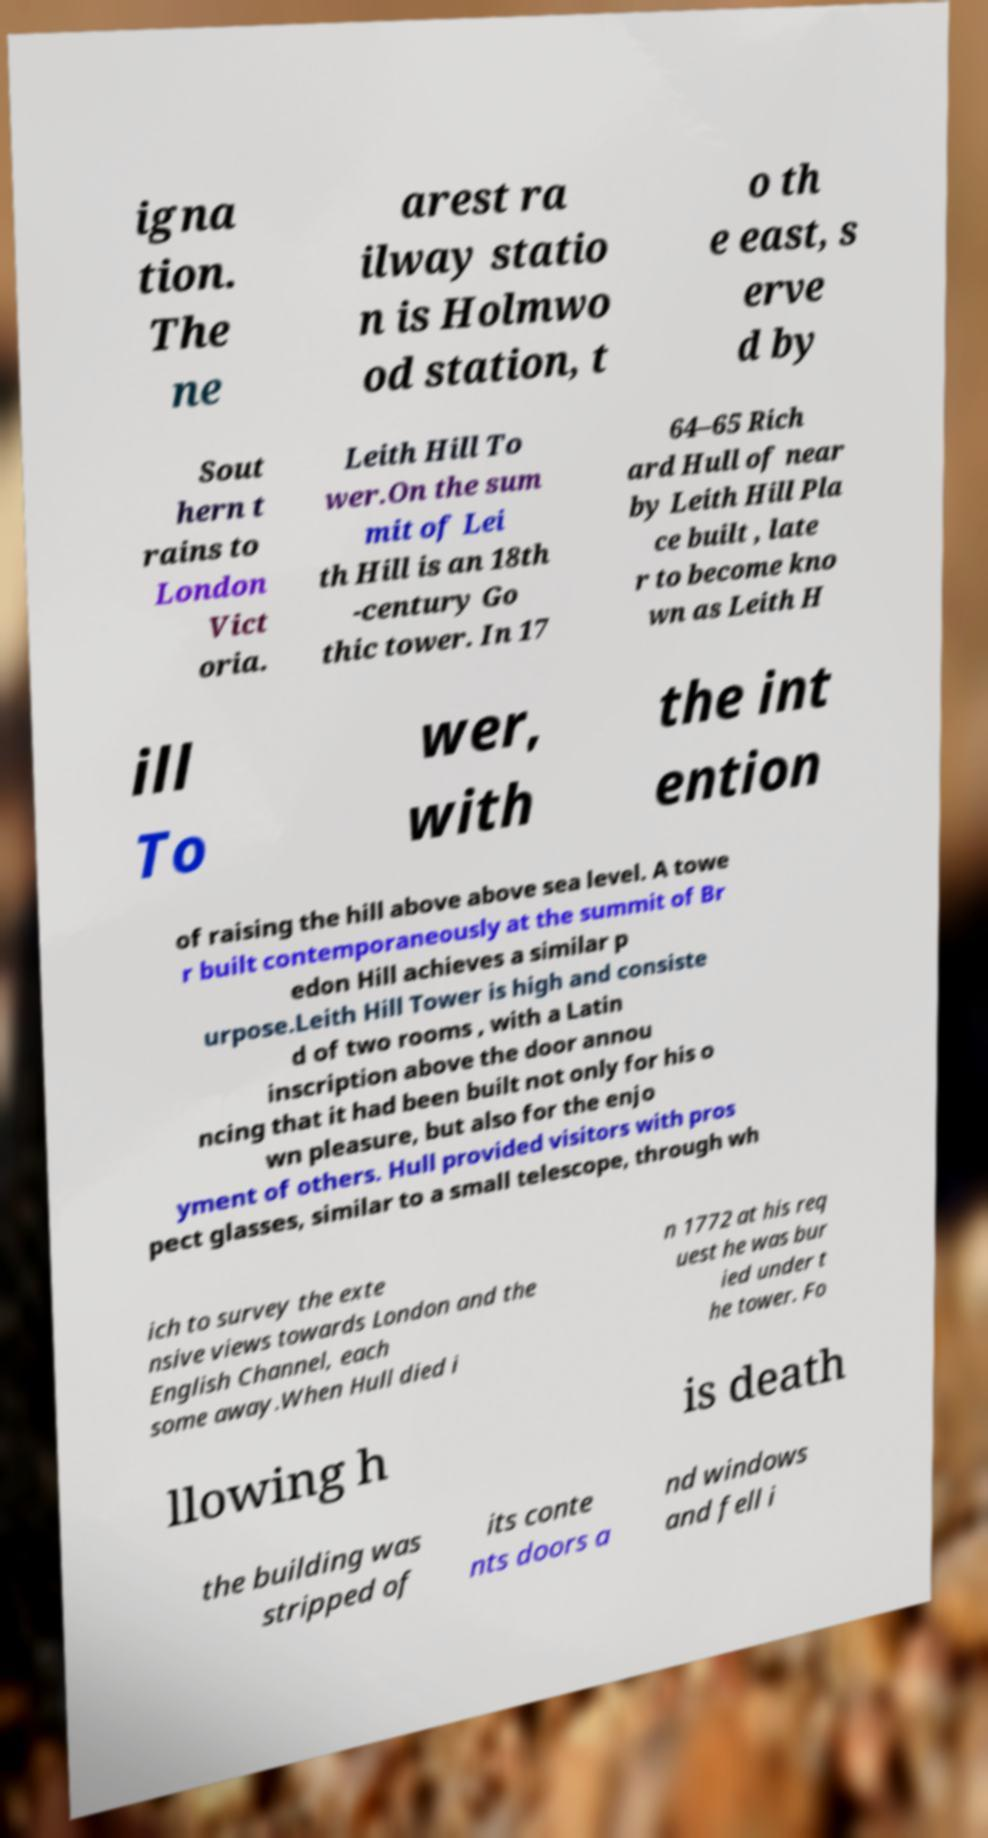For documentation purposes, I need the text within this image transcribed. Could you provide that? igna tion. The ne arest ra ilway statio n is Holmwo od station, t o th e east, s erve d by Sout hern t rains to London Vict oria. Leith Hill To wer.On the sum mit of Lei th Hill is an 18th -century Go thic tower. In 17 64–65 Rich ard Hull of near by Leith Hill Pla ce built , late r to become kno wn as Leith H ill To wer, with the int ention of raising the hill above above sea level. A towe r built contemporaneously at the summit of Br edon Hill achieves a similar p urpose.Leith Hill Tower is high and consiste d of two rooms , with a Latin inscription above the door annou ncing that it had been built not only for his o wn pleasure, but also for the enjo yment of others. Hull provided visitors with pros pect glasses, similar to a small telescope, through wh ich to survey the exte nsive views towards London and the English Channel, each some away.When Hull died i n 1772 at his req uest he was bur ied under t he tower. Fo llowing h is death the building was stripped of its conte nts doors a nd windows and fell i 